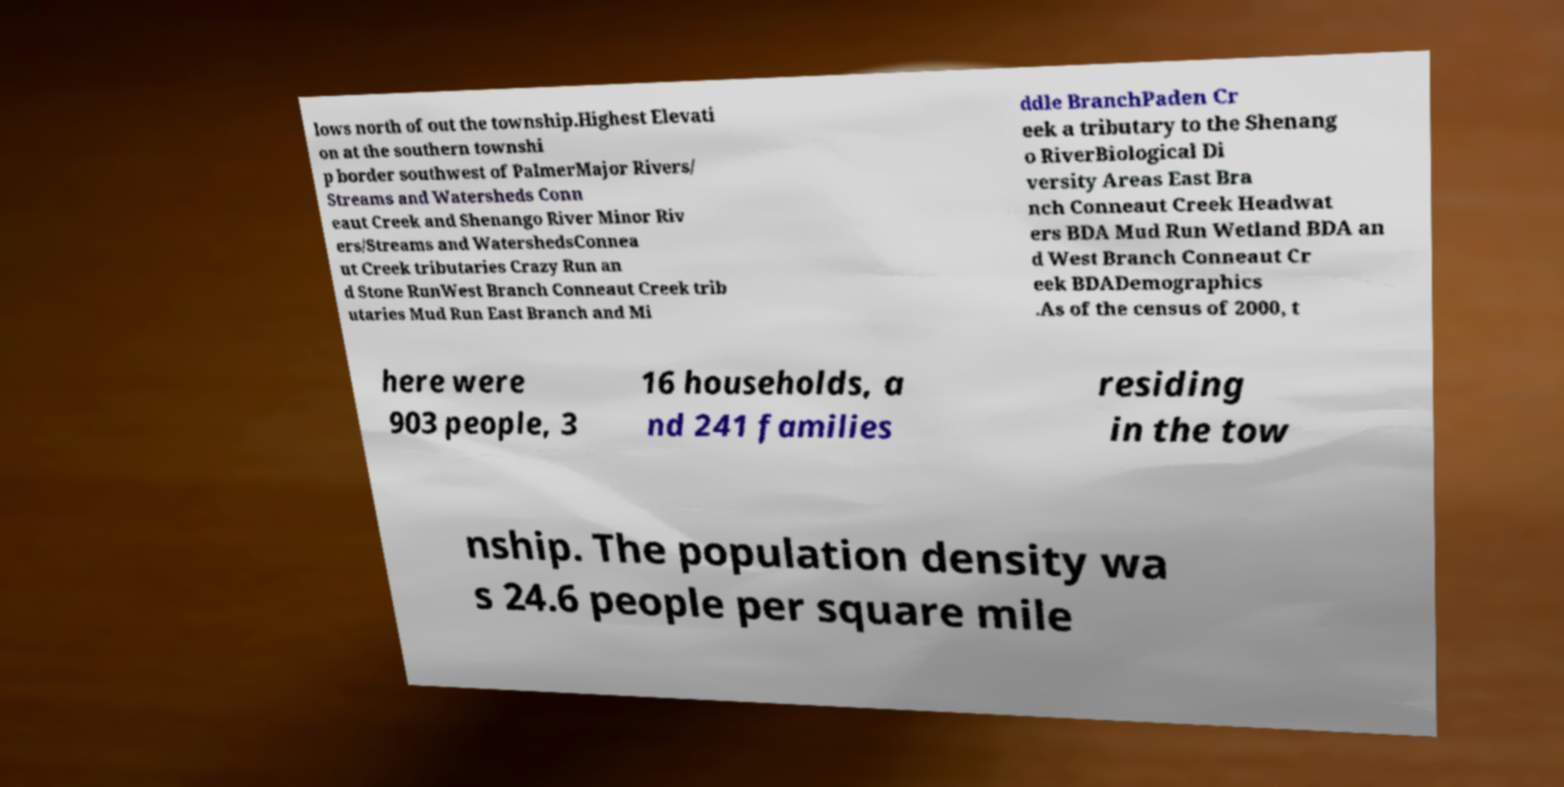Please read and relay the text visible in this image. What does it say? lows north of out the township.Highest Elevati on at the southern townshi p border southwest of PalmerMajor Rivers/ Streams and Watersheds Conn eaut Creek and Shenango River Minor Riv ers/Streams and WatershedsConnea ut Creek tributaries Crazy Run an d Stone RunWest Branch Conneaut Creek trib utaries Mud Run East Branch and Mi ddle BranchPaden Cr eek a tributary to the Shenang o RiverBiological Di versity Areas East Bra nch Conneaut Creek Headwat ers BDA Mud Run Wetland BDA an d West Branch Conneaut Cr eek BDADemographics .As of the census of 2000, t here were 903 people, 3 16 households, a nd 241 families residing in the tow nship. The population density wa s 24.6 people per square mile 